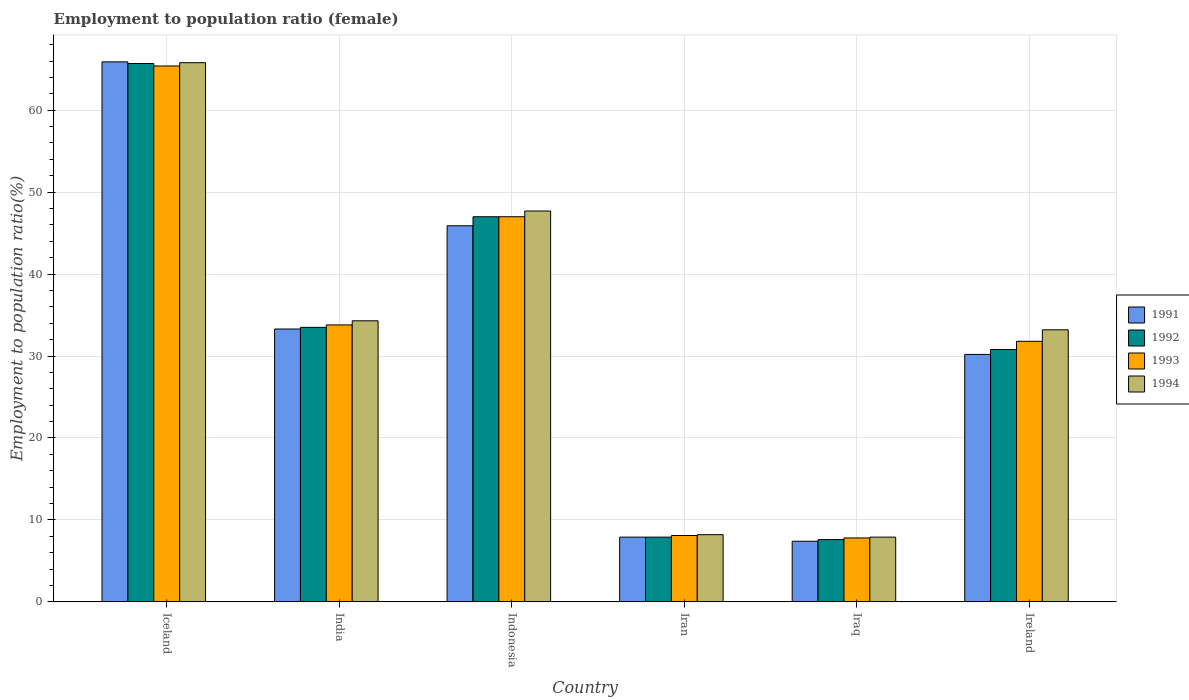Are the number of bars per tick equal to the number of legend labels?
Your answer should be very brief. Yes. How many bars are there on the 2nd tick from the left?
Keep it short and to the point. 4. What is the label of the 3rd group of bars from the left?
Give a very brief answer. Indonesia. In how many cases, is the number of bars for a given country not equal to the number of legend labels?
Your response must be concise. 0. What is the employment to population ratio in 1993 in Iraq?
Your response must be concise. 7.8. Across all countries, what is the maximum employment to population ratio in 1993?
Give a very brief answer. 65.4. Across all countries, what is the minimum employment to population ratio in 1994?
Your answer should be very brief. 7.9. In which country was the employment to population ratio in 1994 maximum?
Provide a short and direct response. Iceland. In which country was the employment to population ratio in 1991 minimum?
Give a very brief answer. Iraq. What is the total employment to population ratio in 1994 in the graph?
Ensure brevity in your answer.  197.1. What is the difference between the employment to population ratio in 1991 in Iran and that in Iraq?
Offer a very short reply. 0.5. What is the difference between the employment to population ratio in 1994 in India and the employment to population ratio in 1992 in Iraq?
Make the answer very short. 26.7. What is the average employment to population ratio in 1994 per country?
Offer a terse response. 32.85. What is the difference between the employment to population ratio of/in 1994 and employment to population ratio of/in 1991 in Iceland?
Your answer should be very brief. -0.1. What is the ratio of the employment to population ratio in 1993 in Iran to that in Ireland?
Provide a succinct answer. 0.25. Is the difference between the employment to population ratio in 1994 in Iran and Ireland greater than the difference between the employment to population ratio in 1991 in Iran and Ireland?
Ensure brevity in your answer.  No. What is the difference between the highest and the second highest employment to population ratio in 1993?
Provide a short and direct response. 31.6. What is the difference between the highest and the lowest employment to population ratio in 1992?
Provide a succinct answer. 58.1. Is the sum of the employment to population ratio in 1991 in India and Indonesia greater than the maximum employment to population ratio in 1992 across all countries?
Ensure brevity in your answer.  Yes. Is it the case that in every country, the sum of the employment to population ratio in 1993 and employment to population ratio in 1992 is greater than the employment to population ratio in 1991?
Keep it short and to the point. Yes. How many bars are there?
Offer a very short reply. 24. Does the graph contain grids?
Make the answer very short. Yes. Where does the legend appear in the graph?
Give a very brief answer. Center right. How many legend labels are there?
Provide a succinct answer. 4. How are the legend labels stacked?
Keep it short and to the point. Vertical. What is the title of the graph?
Keep it short and to the point. Employment to population ratio (female). What is the Employment to population ratio(%) in 1991 in Iceland?
Your answer should be compact. 65.9. What is the Employment to population ratio(%) of 1992 in Iceland?
Your answer should be very brief. 65.7. What is the Employment to population ratio(%) of 1993 in Iceland?
Your answer should be compact. 65.4. What is the Employment to population ratio(%) in 1994 in Iceland?
Offer a terse response. 65.8. What is the Employment to population ratio(%) of 1991 in India?
Ensure brevity in your answer.  33.3. What is the Employment to population ratio(%) in 1992 in India?
Your answer should be compact. 33.5. What is the Employment to population ratio(%) of 1993 in India?
Offer a very short reply. 33.8. What is the Employment to population ratio(%) of 1994 in India?
Offer a terse response. 34.3. What is the Employment to population ratio(%) of 1991 in Indonesia?
Give a very brief answer. 45.9. What is the Employment to population ratio(%) of 1993 in Indonesia?
Give a very brief answer. 47. What is the Employment to population ratio(%) of 1994 in Indonesia?
Keep it short and to the point. 47.7. What is the Employment to population ratio(%) of 1991 in Iran?
Your answer should be very brief. 7.9. What is the Employment to population ratio(%) in 1992 in Iran?
Make the answer very short. 7.9. What is the Employment to population ratio(%) of 1993 in Iran?
Make the answer very short. 8.1. What is the Employment to population ratio(%) in 1994 in Iran?
Ensure brevity in your answer.  8.2. What is the Employment to population ratio(%) in 1991 in Iraq?
Ensure brevity in your answer.  7.4. What is the Employment to population ratio(%) of 1992 in Iraq?
Your answer should be compact. 7.6. What is the Employment to population ratio(%) of 1993 in Iraq?
Keep it short and to the point. 7.8. What is the Employment to population ratio(%) of 1994 in Iraq?
Ensure brevity in your answer.  7.9. What is the Employment to population ratio(%) in 1991 in Ireland?
Provide a succinct answer. 30.2. What is the Employment to population ratio(%) of 1992 in Ireland?
Provide a short and direct response. 30.8. What is the Employment to population ratio(%) in 1993 in Ireland?
Provide a succinct answer. 31.8. What is the Employment to population ratio(%) of 1994 in Ireland?
Your response must be concise. 33.2. Across all countries, what is the maximum Employment to population ratio(%) in 1991?
Provide a succinct answer. 65.9. Across all countries, what is the maximum Employment to population ratio(%) of 1992?
Your answer should be very brief. 65.7. Across all countries, what is the maximum Employment to population ratio(%) in 1993?
Your answer should be very brief. 65.4. Across all countries, what is the maximum Employment to population ratio(%) in 1994?
Your response must be concise. 65.8. Across all countries, what is the minimum Employment to population ratio(%) of 1991?
Keep it short and to the point. 7.4. Across all countries, what is the minimum Employment to population ratio(%) in 1992?
Offer a terse response. 7.6. Across all countries, what is the minimum Employment to population ratio(%) in 1993?
Your answer should be compact. 7.8. Across all countries, what is the minimum Employment to population ratio(%) in 1994?
Your response must be concise. 7.9. What is the total Employment to population ratio(%) of 1991 in the graph?
Keep it short and to the point. 190.6. What is the total Employment to population ratio(%) in 1992 in the graph?
Make the answer very short. 192.5. What is the total Employment to population ratio(%) of 1993 in the graph?
Make the answer very short. 193.9. What is the total Employment to population ratio(%) of 1994 in the graph?
Give a very brief answer. 197.1. What is the difference between the Employment to population ratio(%) in 1991 in Iceland and that in India?
Provide a succinct answer. 32.6. What is the difference between the Employment to population ratio(%) in 1992 in Iceland and that in India?
Offer a terse response. 32.2. What is the difference between the Employment to population ratio(%) of 1993 in Iceland and that in India?
Provide a short and direct response. 31.6. What is the difference between the Employment to population ratio(%) in 1994 in Iceland and that in India?
Provide a succinct answer. 31.5. What is the difference between the Employment to population ratio(%) of 1991 in Iceland and that in Iran?
Your response must be concise. 58. What is the difference between the Employment to population ratio(%) of 1992 in Iceland and that in Iran?
Offer a terse response. 57.8. What is the difference between the Employment to population ratio(%) in 1993 in Iceland and that in Iran?
Offer a terse response. 57.3. What is the difference between the Employment to population ratio(%) of 1994 in Iceland and that in Iran?
Give a very brief answer. 57.6. What is the difference between the Employment to population ratio(%) of 1991 in Iceland and that in Iraq?
Make the answer very short. 58.5. What is the difference between the Employment to population ratio(%) of 1992 in Iceland and that in Iraq?
Provide a succinct answer. 58.1. What is the difference between the Employment to population ratio(%) in 1993 in Iceland and that in Iraq?
Provide a succinct answer. 57.6. What is the difference between the Employment to population ratio(%) in 1994 in Iceland and that in Iraq?
Offer a very short reply. 57.9. What is the difference between the Employment to population ratio(%) in 1991 in Iceland and that in Ireland?
Give a very brief answer. 35.7. What is the difference between the Employment to population ratio(%) of 1992 in Iceland and that in Ireland?
Provide a succinct answer. 34.9. What is the difference between the Employment to population ratio(%) of 1993 in Iceland and that in Ireland?
Your response must be concise. 33.6. What is the difference between the Employment to population ratio(%) of 1994 in Iceland and that in Ireland?
Your response must be concise. 32.6. What is the difference between the Employment to population ratio(%) in 1991 in India and that in Indonesia?
Your answer should be very brief. -12.6. What is the difference between the Employment to population ratio(%) in 1992 in India and that in Indonesia?
Your response must be concise. -13.5. What is the difference between the Employment to population ratio(%) of 1991 in India and that in Iran?
Your answer should be very brief. 25.4. What is the difference between the Employment to population ratio(%) of 1992 in India and that in Iran?
Make the answer very short. 25.6. What is the difference between the Employment to population ratio(%) of 1993 in India and that in Iran?
Give a very brief answer. 25.7. What is the difference between the Employment to population ratio(%) in 1994 in India and that in Iran?
Offer a very short reply. 26.1. What is the difference between the Employment to population ratio(%) of 1991 in India and that in Iraq?
Make the answer very short. 25.9. What is the difference between the Employment to population ratio(%) of 1992 in India and that in Iraq?
Offer a very short reply. 25.9. What is the difference between the Employment to population ratio(%) of 1993 in India and that in Iraq?
Give a very brief answer. 26. What is the difference between the Employment to population ratio(%) of 1994 in India and that in Iraq?
Make the answer very short. 26.4. What is the difference between the Employment to population ratio(%) of 1991 in India and that in Ireland?
Offer a terse response. 3.1. What is the difference between the Employment to population ratio(%) in 1992 in India and that in Ireland?
Offer a terse response. 2.7. What is the difference between the Employment to population ratio(%) in 1994 in India and that in Ireland?
Offer a terse response. 1.1. What is the difference between the Employment to population ratio(%) of 1992 in Indonesia and that in Iran?
Provide a short and direct response. 39.1. What is the difference between the Employment to population ratio(%) in 1993 in Indonesia and that in Iran?
Offer a very short reply. 38.9. What is the difference between the Employment to population ratio(%) in 1994 in Indonesia and that in Iran?
Give a very brief answer. 39.5. What is the difference between the Employment to population ratio(%) in 1991 in Indonesia and that in Iraq?
Your answer should be compact. 38.5. What is the difference between the Employment to population ratio(%) of 1992 in Indonesia and that in Iraq?
Offer a very short reply. 39.4. What is the difference between the Employment to population ratio(%) of 1993 in Indonesia and that in Iraq?
Give a very brief answer. 39.2. What is the difference between the Employment to population ratio(%) of 1994 in Indonesia and that in Iraq?
Your response must be concise. 39.8. What is the difference between the Employment to population ratio(%) in 1994 in Indonesia and that in Ireland?
Offer a very short reply. 14.5. What is the difference between the Employment to population ratio(%) of 1991 in Iran and that in Iraq?
Your response must be concise. 0.5. What is the difference between the Employment to population ratio(%) in 1991 in Iran and that in Ireland?
Your response must be concise. -22.3. What is the difference between the Employment to population ratio(%) of 1992 in Iran and that in Ireland?
Provide a succinct answer. -22.9. What is the difference between the Employment to population ratio(%) in 1993 in Iran and that in Ireland?
Make the answer very short. -23.7. What is the difference between the Employment to population ratio(%) of 1991 in Iraq and that in Ireland?
Provide a short and direct response. -22.8. What is the difference between the Employment to population ratio(%) in 1992 in Iraq and that in Ireland?
Give a very brief answer. -23.2. What is the difference between the Employment to population ratio(%) of 1994 in Iraq and that in Ireland?
Give a very brief answer. -25.3. What is the difference between the Employment to population ratio(%) of 1991 in Iceland and the Employment to population ratio(%) of 1992 in India?
Your answer should be very brief. 32.4. What is the difference between the Employment to population ratio(%) in 1991 in Iceland and the Employment to population ratio(%) in 1993 in India?
Offer a very short reply. 32.1. What is the difference between the Employment to population ratio(%) in 1991 in Iceland and the Employment to population ratio(%) in 1994 in India?
Provide a succinct answer. 31.6. What is the difference between the Employment to population ratio(%) in 1992 in Iceland and the Employment to population ratio(%) in 1993 in India?
Your answer should be very brief. 31.9. What is the difference between the Employment to population ratio(%) of 1992 in Iceland and the Employment to population ratio(%) of 1994 in India?
Ensure brevity in your answer.  31.4. What is the difference between the Employment to population ratio(%) in 1993 in Iceland and the Employment to population ratio(%) in 1994 in India?
Your answer should be very brief. 31.1. What is the difference between the Employment to population ratio(%) of 1991 in Iceland and the Employment to population ratio(%) of 1992 in Indonesia?
Your answer should be very brief. 18.9. What is the difference between the Employment to population ratio(%) of 1992 in Iceland and the Employment to population ratio(%) of 1994 in Indonesia?
Your answer should be compact. 18. What is the difference between the Employment to population ratio(%) in 1993 in Iceland and the Employment to population ratio(%) in 1994 in Indonesia?
Offer a very short reply. 17.7. What is the difference between the Employment to population ratio(%) of 1991 in Iceland and the Employment to population ratio(%) of 1992 in Iran?
Your response must be concise. 58. What is the difference between the Employment to population ratio(%) of 1991 in Iceland and the Employment to population ratio(%) of 1993 in Iran?
Ensure brevity in your answer.  57.8. What is the difference between the Employment to population ratio(%) of 1991 in Iceland and the Employment to population ratio(%) of 1994 in Iran?
Your answer should be compact. 57.7. What is the difference between the Employment to population ratio(%) of 1992 in Iceland and the Employment to population ratio(%) of 1993 in Iran?
Ensure brevity in your answer.  57.6. What is the difference between the Employment to population ratio(%) in 1992 in Iceland and the Employment to population ratio(%) in 1994 in Iran?
Your answer should be compact. 57.5. What is the difference between the Employment to population ratio(%) in 1993 in Iceland and the Employment to population ratio(%) in 1994 in Iran?
Make the answer very short. 57.2. What is the difference between the Employment to population ratio(%) of 1991 in Iceland and the Employment to population ratio(%) of 1992 in Iraq?
Your answer should be compact. 58.3. What is the difference between the Employment to population ratio(%) of 1991 in Iceland and the Employment to population ratio(%) of 1993 in Iraq?
Your answer should be very brief. 58.1. What is the difference between the Employment to population ratio(%) in 1991 in Iceland and the Employment to population ratio(%) in 1994 in Iraq?
Offer a terse response. 58. What is the difference between the Employment to population ratio(%) of 1992 in Iceland and the Employment to population ratio(%) of 1993 in Iraq?
Your answer should be very brief. 57.9. What is the difference between the Employment to population ratio(%) of 1992 in Iceland and the Employment to population ratio(%) of 1994 in Iraq?
Offer a terse response. 57.8. What is the difference between the Employment to population ratio(%) in 1993 in Iceland and the Employment to population ratio(%) in 1994 in Iraq?
Your answer should be very brief. 57.5. What is the difference between the Employment to population ratio(%) of 1991 in Iceland and the Employment to population ratio(%) of 1992 in Ireland?
Your response must be concise. 35.1. What is the difference between the Employment to population ratio(%) of 1991 in Iceland and the Employment to population ratio(%) of 1993 in Ireland?
Ensure brevity in your answer.  34.1. What is the difference between the Employment to population ratio(%) in 1991 in Iceland and the Employment to population ratio(%) in 1994 in Ireland?
Provide a succinct answer. 32.7. What is the difference between the Employment to population ratio(%) in 1992 in Iceland and the Employment to population ratio(%) in 1993 in Ireland?
Your answer should be compact. 33.9. What is the difference between the Employment to population ratio(%) of 1992 in Iceland and the Employment to population ratio(%) of 1994 in Ireland?
Provide a succinct answer. 32.5. What is the difference between the Employment to population ratio(%) in 1993 in Iceland and the Employment to population ratio(%) in 1994 in Ireland?
Make the answer very short. 32.2. What is the difference between the Employment to population ratio(%) in 1991 in India and the Employment to population ratio(%) in 1992 in Indonesia?
Your answer should be very brief. -13.7. What is the difference between the Employment to population ratio(%) in 1991 in India and the Employment to population ratio(%) in 1993 in Indonesia?
Make the answer very short. -13.7. What is the difference between the Employment to population ratio(%) of 1991 in India and the Employment to population ratio(%) of 1994 in Indonesia?
Make the answer very short. -14.4. What is the difference between the Employment to population ratio(%) in 1992 in India and the Employment to population ratio(%) in 1994 in Indonesia?
Your answer should be very brief. -14.2. What is the difference between the Employment to population ratio(%) of 1993 in India and the Employment to population ratio(%) of 1994 in Indonesia?
Your response must be concise. -13.9. What is the difference between the Employment to population ratio(%) of 1991 in India and the Employment to population ratio(%) of 1992 in Iran?
Ensure brevity in your answer.  25.4. What is the difference between the Employment to population ratio(%) of 1991 in India and the Employment to population ratio(%) of 1993 in Iran?
Ensure brevity in your answer.  25.2. What is the difference between the Employment to population ratio(%) of 1991 in India and the Employment to population ratio(%) of 1994 in Iran?
Provide a succinct answer. 25.1. What is the difference between the Employment to population ratio(%) in 1992 in India and the Employment to population ratio(%) in 1993 in Iran?
Give a very brief answer. 25.4. What is the difference between the Employment to population ratio(%) of 1992 in India and the Employment to population ratio(%) of 1994 in Iran?
Make the answer very short. 25.3. What is the difference between the Employment to population ratio(%) of 1993 in India and the Employment to population ratio(%) of 1994 in Iran?
Ensure brevity in your answer.  25.6. What is the difference between the Employment to population ratio(%) of 1991 in India and the Employment to population ratio(%) of 1992 in Iraq?
Offer a terse response. 25.7. What is the difference between the Employment to population ratio(%) in 1991 in India and the Employment to population ratio(%) in 1994 in Iraq?
Ensure brevity in your answer.  25.4. What is the difference between the Employment to population ratio(%) of 1992 in India and the Employment to population ratio(%) of 1993 in Iraq?
Offer a very short reply. 25.7. What is the difference between the Employment to population ratio(%) of 1992 in India and the Employment to population ratio(%) of 1994 in Iraq?
Make the answer very short. 25.6. What is the difference between the Employment to population ratio(%) of 1993 in India and the Employment to population ratio(%) of 1994 in Iraq?
Make the answer very short. 25.9. What is the difference between the Employment to population ratio(%) in 1992 in India and the Employment to population ratio(%) in 1994 in Ireland?
Offer a terse response. 0.3. What is the difference between the Employment to population ratio(%) in 1993 in India and the Employment to population ratio(%) in 1994 in Ireland?
Offer a very short reply. 0.6. What is the difference between the Employment to population ratio(%) in 1991 in Indonesia and the Employment to population ratio(%) in 1993 in Iran?
Offer a terse response. 37.8. What is the difference between the Employment to population ratio(%) in 1991 in Indonesia and the Employment to population ratio(%) in 1994 in Iran?
Your response must be concise. 37.7. What is the difference between the Employment to population ratio(%) in 1992 in Indonesia and the Employment to population ratio(%) in 1993 in Iran?
Give a very brief answer. 38.9. What is the difference between the Employment to population ratio(%) in 1992 in Indonesia and the Employment to population ratio(%) in 1994 in Iran?
Offer a terse response. 38.8. What is the difference between the Employment to population ratio(%) in 1993 in Indonesia and the Employment to population ratio(%) in 1994 in Iran?
Provide a short and direct response. 38.8. What is the difference between the Employment to population ratio(%) in 1991 in Indonesia and the Employment to population ratio(%) in 1992 in Iraq?
Ensure brevity in your answer.  38.3. What is the difference between the Employment to population ratio(%) in 1991 in Indonesia and the Employment to population ratio(%) in 1993 in Iraq?
Offer a very short reply. 38.1. What is the difference between the Employment to population ratio(%) of 1991 in Indonesia and the Employment to population ratio(%) of 1994 in Iraq?
Your response must be concise. 38. What is the difference between the Employment to population ratio(%) in 1992 in Indonesia and the Employment to population ratio(%) in 1993 in Iraq?
Ensure brevity in your answer.  39.2. What is the difference between the Employment to population ratio(%) of 1992 in Indonesia and the Employment to population ratio(%) of 1994 in Iraq?
Make the answer very short. 39.1. What is the difference between the Employment to population ratio(%) in 1993 in Indonesia and the Employment to population ratio(%) in 1994 in Iraq?
Give a very brief answer. 39.1. What is the difference between the Employment to population ratio(%) in 1991 in Indonesia and the Employment to population ratio(%) in 1992 in Ireland?
Your answer should be very brief. 15.1. What is the difference between the Employment to population ratio(%) of 1991 in Indonesia and the Employment to population ratio(%) of 1994 in Ireland?
Ensure brevity in your answer.  12.7. What is the difference between the Employment to population ratio(%) in 1992 in Indonesia and the Employment to population ratio(%) in 1993 in Ireland?
Offer a very short reply. 15.2. What is the difference between the Employment to population ratio(%) of 1993 in Indonesia and the Employment to population ratio(%) of 1994 in Ireland?
Provide a short and direct response. 13.8. What is the difference between the Employment to population ratio(%) of 1991 in Iran and the Employment to population ratio(%) of 1992 in Iraq?
Your answer should be compact. 0.3. What is the difference between the Employment to population ratio(%) of 1991 in Iran and the Employment to population ratio(%) of 1993 in Iraq?
Offer a terse response. 0.1. What is the difference between the Employment to population ratio(%) in 1992 in Iran and the Employment to population ratio(%) in 1993 in Iraq?
Ensure brevity in your answer.  0.1. What is the difference between the Employment to population ratio(%) in 1993 in Iran and the Employment to population ratio(%) in 1994 in Iraq?
Provide a short and direct response. 0.2. What is the difference between the Employment to population ratio(%) in 1991 in Iran and the Employment to population ratio(%) in 1992 in Ireland?
Give a very brief answer. -22.9. What is the difference between the Employment to population ratio(%) of 1991 in Iran and the Employment to population ratio(%) of 1993 in Ireland?
Make the answer very short. -23.9. What is the difference between the Employment to population ratio(%) of 1991 in Iran and the Employment to population ratio(%) of 1994 in Ireland?
Your answer should be compact. -25.3. What is the difference between the Employment to population ratio(%) of 1992 in Iran and the Employment to population ratio(%) of 1993 in Ireland?
Make the answer very short. -23.9. What is the difference between the Employment to population ratio(%) in 1992 in Iran and the Employment to population ratio(%) in 1994 in Ireland?
Provide a succinct answer. -25.3. What is the difference between the Employment to population ratio(%) in 1993 in Iran and the Employment to population ratio(%) in 1994 in Ireland?
Offer a very short reply. -25.1. What is the difference between the Employment to population ratio(%) of 1991 in Iraq and the Employment to population ratio(%) of 1992 in Ireland?
Your response must be concise. -23.4. What is the difference between the Employment to population ratio(%) of 1991 in Iraq and the Employment to population ratio(%) of 1993 in Ireland?
Provide a succinct answer. -24.4. What is the difference between the Employment to population ratio(%) of 1991 in Iraq and the Employment to population ratio(%) of 1994 in Ireland?
Provide a short and direct response. -25.8. What is the difference between the Employment to population ratio(%) in 1992 in Iraq and the Employment to population ratio(%) in 1993 in Ireland?
Offer a very short reply. -24.2. What is the difference between the Employment to population ratio(%) in 1992 in Iraq and the Employment to population ratio(%) in 1994 in Ireland?
Your answer should be compact. -25.6. What is the difference between the Employment to population ratio(%) in 1993 in Iraq and the Employment to population ratio(%) in 1994 in Ireland?
Offer a very short reply. -25.4. What is the average Employment to population ratio(%) in 1991 per country?
Offer a terse response. 31.77. What is the average Employment to population ratio(%) of 1992 per country?
Keep it short and to the point. 32.08. What is the average Employment to population ratio(%) of 1993 per country?
Give a very brief answer. 32.32. What is the average Employment to population ratio(%) of 1994 per country?
Your answer should be compact. 32.85. What is the difference between the Employment to population ratio(%) of 1991 and Employment to population ratio(%) of 1992 in Iceland?
Provide a succinct answer. 0.2. What is the difference between the Employment to population ratio(%) of 1991 and Employment to population ratio(%) of 1993 in Iceland?
Offer a terse response. 0.5. What is the difference between the Employment to population ratio(%) of 1991 and Employment to population ratio(%) of 1994 in Iceland?
Your answer should be very brief. 0.1. What is the difference between the Employment to population ratio(%) of 1992 and Employment to population ratio(%) of 1994 in Iceland?
Ensure brevity in your answer.  -0.1. What is the difference between the Employment to population ratio(%) of 1993 and Employment to population ratio(%) of 1994 in Iceland?
Offer a terse response. -0.4. What is the difference between the Employment to population ratio(%) of 1991 and Employment to population ratio(%) of 1992 in India?
Ensure brevity in your answer.  -0.2. What is the difference between the Employment to population ratio(%) of 1991 and Employment to population ratio(%) of 1993 in India?
Make the answer very short. -0.5. What is the difference between the Employment to population ratio(%) in 1992 and Employment to population ratio(%) in 1993 in India?
Offer a terse response. -0.3. What is the difference between the Employment to population ratio(%) of 1992 and Employment to population ratio(%) of 1994 in India?
Your answer should be compact. -0.8. What is the difference between the Employment to population ratio(%) in 1993 and Employment to population ratio(%) in 1994 in India?
Offer a very short reply. -0.5. What is the difference between the Employment to population ratio(%) in 1991 and Employment to population ratio(%) in 1994 in Indonesia?
Make the answer very short. -1.8. What is the difference between the Employment to population ratio(%) in 1992 and Employment to population ratio(%) in 1993 in Indonesia?
Ensure brevity in your answer.  0. What is the difference between the Employment to population ratio(%) of 1993 and Employment to population ratio(%) of 1994 in Indonesia?
Provide a short and direct response. -0.7. What is the difference between the Employment to population ratio(%) in 1991 and Employment to population ratio(%) in 1992 in Iran?
Your answer should be compact. 0. What is the difference between the Employment to population ratio(%) of 1992 and Employment to population ratio(%) of 1993 in Iran?
Offer a very short reply. -0.2. What is the difference between the Employment to population ratio(%) in 1993 and Employment to population ratio(%) in 1994 in Iran?
Your response must be concise. -0.1. What is the difference between the Employment to population ratio(%) in 1991 and Employment to population ratio(%) in 1993 in Iraq?
Your response must be concise. -0.4. What is the difference between the Employment to population ratio(%) of 1991 and Employment to population ratio(%) of 1994 in Iraq?
Ensure brevity in your answer.  -0.5. What is the difference between the Employment to population ratio(%) in 1992 and Employment to population ratio(%) in 1994 in Iraq?
Your answer should be very brief. -0.3. What is the difference between the Employment to population ratio(%) of 1991 and Employment to population ratio(%) of 1992 in Ireland?
Offer a terse response. -0.6. What is the difference between the Employment to population ratio(%) of 1991 and Employment to population ratio(%) of 1994 in Ireland?
Give a very brief answer. -3. What is the difference between the Employment to population ratio(%) of 1992 and Employment to population ratio(%) of 1994 in Ireland?
Offer a terse response. -2.4. What is the difference between the Employment to population ratio(%) of 1993 and Employment to population ratio(%) of 1994 in Ireland?
Make the answer very short. -1.4. What is the ratio of the Employment to population ratio(%) in 1991 in Iceland to that in India?
Give a very brief answer. 1.98. What is the ratio of the Employment to population ratio(%) of 1992 in Iceland to that in India?
Your answer should be very brief. 1.96. What is the ratio of the Employment to population ratio(%) of 1993 in Iceland to that in India?
Offer a terse response. 1.93. What is the ratio of the Employment to population ratio(%) in 1994 in Iceland to that in India?
Keep it short and to the point. 1.92. What is the ratio of the Employment to population ratio(%) in 1991 in Iceland to that in Indonesia?
Make the answer very short. 1.44. What is the ratio of the Employment to population ratio(%) in 1992 in Iceland to that in Indonesia?
Offer a very short reply. 1.4. What is the ratio of the Employment to population ratio(%) in 1993 in Iceland to that in Indonesia?
Provide a short and direct response. 1.39. What is the ratio of the Employment to population ratio(%) in 1994 in Iceland to that in Indonesia?
Your answer should be very brief. 1.38. What is the ratio of the Employment to population ratio(%) in 1991 in Iceland to that in Iran?
Offer a very short reply. 8.34. What is the ratio of the Employment to population ratio(%) in 1992 in Iceland to that in Iran?
Your answer should be very brief. 8.32. What is the ratio of the Employment to population ratio(%) in 1993 in Iceland to that in Iran?
Your response must be concise. 8.07. What is the ratio of the Employment to population ratio(%) of 1994 in Iceland to that in Iran?
Offer a very short reply. 8.02. What is the ratio of the Employment to population ratio(%) of 1991 in Iceland to that in Iraq?
Provide a short and direct response. 8.91. What is the ratio of the Employment to population ratio(%) of 1992 in Iceland to that in Iraq?
Offer a very short reply. 8.64. What is the ratio of the Employment to population ratio(%) of 1993 in Iceland to that in Iraq?
Ensure brevity in your answer.  8.38. What is the ratio of the Employment to population ratio(%) in 1994 in Iceland to that in Iraq?
Ensure brevity in your answer.  8.33. What is the ratio of the Employment to population ratio(%) in 1991 in Iceland to that in Ireland?
Offer a very short reply. 2.18. What is the ratio of the Employment to population ratio(%) of 1992 in Iceland to that in Ireland?
Offer a very short reply. 2.13. What is the ratio of the Employment to population ratio(%) of 1993 in Iceland to that in Ireland?
Your answer should be compact. 2.06. What is the ratio of the Employment to population ratio(%) in 1994 in Iceland to that in Ireland?
Your response must be concise. 1.98. What is the ratio of the Employment to population ratio(%) of 1991 in India to that in Indonesia?
Your answer should be very brief. 0.73. What is the ratio of the Employment to population ratio(%) of 1992 in India to that in Indonesia?
Your answer should be compact. 0.71. What is the ratio of the Employment to population ratio(%) in 1993 in India to that in Indonesia?
Keep it short and to the point. 0.72. What is the ratio of the Employment to population ratio(%) of 1994 in India to that in Indonesia?
Provide a succinct answer. 0.72. What is the ratio of the Employment to population ratio(%) of 1991 in India to that in Iran?
Provide a short and direct response. 4.22. What is the ratio of the Employment to population ratio(%) in 1992 in India to that in Iran?
Keep it short and to the point. 4.24. What is the ratio of the Employment to population ratio(%) of 1993 in India to that in Iran?
Keep it short and to the point. 4.17. What is the ratio of the Employment to population ratio(%) of 1994 in India to that in Iran?
Your response must be concise. 4.18. What is the ratio of the Employment to population ratio(%) of 1991 in India to that in Iraq?
Provide a succinct answer. 4.5. What is the ratio of the Employment to population ratio(%) of 1992 in India to that in Iraq?
Ensure brevity in your answer.  4.41. What is the ratio of the Employment to population ratio(%) of 1993 in India to that in Iraq?
Make the answer very short. 4.33. What is the ratio of the Employment to population ratio(%) of 1994 in India to that in Iraq?
Give a very brief answer. 4.34. What is the ratio of the Employment to population ratio(%) in 1991 in India to that in Ireland?
Ensure brevity in your answer.  1.1. What is the ratio of the Employment to population ratio(%) in 1992 in India to that in Ireland?
Offer a terse response. 1.09. What is the ratio of the Employment to population ratio(%) of 1993 in India to that in Ireland?
Offer a very short reply. 1.06. What is the ratio of the Employment to population ratio(%) of 1994 in India to that in Ireland?
Ensure brevity in your answer.  1.03. What is the ratio of the Employment to population ratio(%) in 1991 in Indonesia to that in Iran?
Make the answer very short. 5.81. What is the ratio of the Employment to population ratio(%) of 1992 in Indonesia to that in Iran?
Your response must be concise. 5.95. What is the ratio of the Employment to population ratio(%) in 1993 in Indonesia to that in Iran?
Offer a terse response. 5.8. What is the ratio of the Employment to population ratio(%) in 1994 in Indonesia to that in Iran?
Offer a very short reply. 5.82. What is the ratio of the Employment to population ratio(%) in 1991 in Indonesia to that in Iraq?
Keep it short and to the point. 6.2. What is the ratio of the Employment to population ratio(%) of 1992 in Indonesia to that in Iraq?
Provide a succinct answer. 6.18. What is the ratio of the Employment to population ratio(%) in 1993 in Indonesia to that in Iraq?
Your response must be concise. 6.03. What is the ratio of the Employment to population ratio(%) of 1994 in Indonesia to that in Iraq?
Keep it short and to the point. 6.04. What is the ratio of the Employment to population ratio(%) in 1991 in Indonesia to that in Ireland?
Provide a succinct answer. 1.52. What is the ratio of the Employment to population ratio(%) of 1992 in Indonesia to that in Ireland?
Make the answer very short. 1.53. What is the ratio of the Employment to population ratio(%) in 1993 in Indonesia to that in Ireland?
Make the answer very short. 1.48. What is the ratio of the Employment to population ratio(%) in 1994 in Indonesia to that in Ireland?
Make the answer very short. 1.44. What is the ratio of the Employment to population ratio(%) of 1991 in Iran to that in Iraq?
Provide a short and direct response. 1.07. What is the ratio of the Employment to population ratio(%) of 1992 in Iran to that in Iraq?
Your answer should be very brief. 1.04. What is the ratio of the Employment to population ratio(%) in 1993 in Iran to that in Iraq?
Your answer should be compact. 1.04. What is the ratio of the Employment to population ratio(%) of 1994 in Iran to that in Iraq?
Make the answer very short. 1.04. What is the ratio of the Employment to population ratio(%) in 1991 in Iran to that in Ireland?
Give a very brief answer. 0.26. What is the ratio of the Employment to population ratio(%) of 1992 in Iran to that in Ireland?
Make the answer very short. 0.26. What is the ratio of the Employment to population ratio(%) in 1993 in Iran to that in Ireland?
Offer a very short reply. 0.25. What is the ratio of the Employment to population ratio(%) in 1994 in Iran to that in Ireland?
Make the answer very short. 0.25. What is the ratio of the Employment to population ratio(%) in 1991 in Iraq to that in Ireland?
Offer a very short reply. 0.24. What is the ratio of the Employment to population ratio(%) in 1992 in Iraq to that in Ireland?
Your answer should be very brief. 0.25. What is the ratio of the Employment to population ratio(%) of 1993 in Iraq to that in Ireland?
Provide a succinct answer. 0.25. What is the ratio of the Employment to population ratio(%) of 1994 in Iraq to that in Ireland?
Give a very brief answer. 0.24. What is the difference between the highest and the lowest Employment to population ratio(%) in 1991?
Your response must be concise. 58.5. What is the difference between the highest and the lowest Employment to population ratio(%) of 1992?
Make the answer very short. 58.1. What is the difference between the highest and the lowest Employment to population ratio(%) in 1993?
Ensure brevity in your answer.  57.6. What is the difference between the highest and the lowest Employment to population ratio(%) in 1994?
Give a very brief answer. 57.9. 